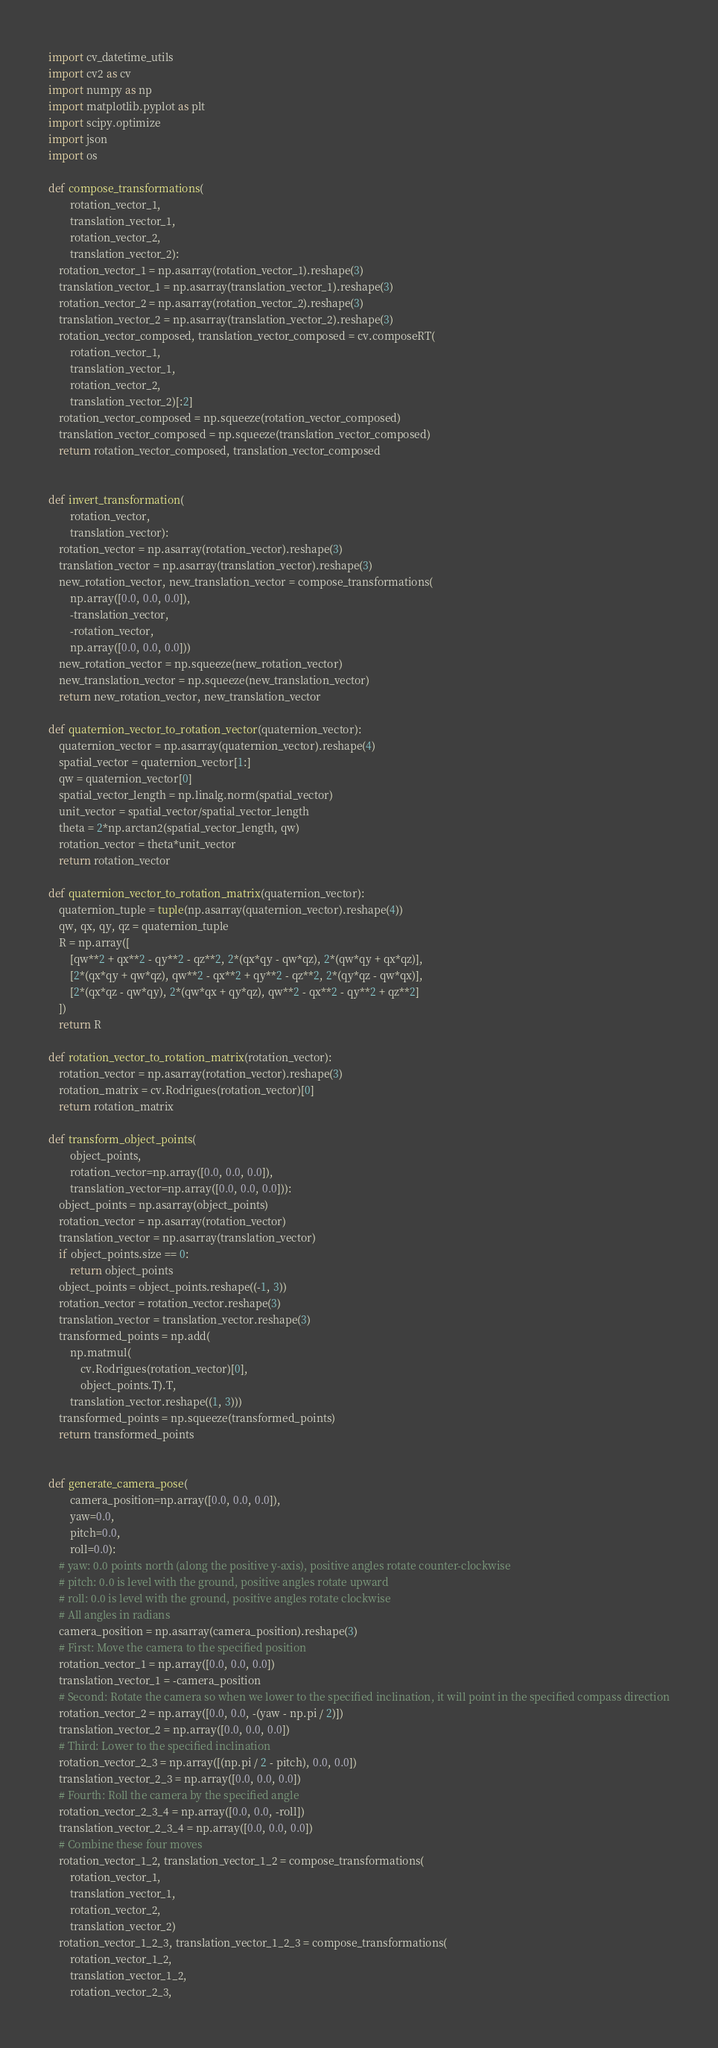Convert code to text. <code><loc_0><loc_0><loc_500><loc_500><_Python_>import cv_datetime_utils
import cv2 as cv
import numpy as np
import matplotlib.pyplot as plt
import scipy.optimize
import json
import os

def compose_transformations(
        rotation_vector_1,
        translation_vector_1,
        rotation_vector_2,
        translation_vector_2):
    rotation_vector_1 = np.asarray(rotation_vector_1).reshape(3)
    translation_vector_1 = np.asarray(translation_vector_1).reshape(3)
    rotation_vector_2 = np.asarray(rotation_vector_2).reshape(3)
    translation_vector_2 = np.asarray(translation_vector_2).reshape(3)
    rotation_vector_composed, translation_vector_composed = cv.composeRT(
        rotation_vector_1,
        translation_vector_1,
        rotation_vector_2,
        translation_vector_2)[:2]
    rotation_vector_composed = np.squeeze(rotation_vector_composed)
    translation_vector_composed = np.squeeze(translation_vector_composed)
    return rotation_vector_composed, translation_vector_composed


def invert_transformation(
        rotation_vector,
        translation_vector):
    rotation_vector = np.asarray(rotation_vector).reshape(3)
    translation_vector = np.asarray(translation_vector).reshape(3)
    new_rotation_vector, new_translation_vector = compose_transformations(
        np.array([0.0, 0.0, 0.0]),
        -translation_vector,
        -rotation_vector,
        np.array([0.0, 0.0, 0.0]))
    new_rotation_vector = np.squeeze(new_rotation_vector)
    new_translation_vector = np.squeeze(new_translation_vector)
    return new_rotation_vector, new_translation_vector

def quaternion_vector_to_rotation_vector(quaternion_vector):
    quaternion_vector = np.asarray(quaternion_vector).reshape(4)
    spatial_vector = quaternion_vector[1:]
    qw = quaternion_vector[0]
    spatial_vector_length = np.linalg.norm(spatial_vector)
    unit_vector = spatial_vector/spatial_vector_length
    theta = 2*np.arctan2(spatial_vector_length, qw)
    rotation_vector = theta*unit_vector
    return rotation_vector

def quaternion_vector_to_rotation_matrix(quaternion_vector):
    quaternion_tuple = tuple(np.asarray(quaternion_vector).reshape(4))
    qw, qx, qy, qz = quaternion_tuple
    R = np.array([
        [qw**2 + qx**2 - qy**2 - qz**2, 2*(qx*qy - qw*qz), 2*(qw*qy + qx*qz)],
        [2*(qx*qy + qw*qz), qw**2 - qx**2 + qy**2 - qz**2, 2*(qy*qz - qw*qx)],
        [2*(qx*qz - qw*qy), 2*(qw*qx + qy*qz), qw**2 - qx**2 - qy**2 + qz**2]
    ])
    return R

def rotation_vector_to_rotation_matrix(rotation_vector):
    rotation_vector = np.asarray(rotation_vector).reshape(3)
    rotation_matrix = cv.Rodrigues(rotation_vector)[0]
    return rotation_matrix

def transform_object_points(
        object_points,
        rotation_vector=np.array([0.0, 0.0, 0.0]),
        translation_vector=np.array([0.0, 0.0, 0.0])):
    object_points = np.asarray(object_points)
    rotation_vector = np.asarray(rotation_vector)
    translation_vector = np.asarray(translation_vector)
    if object_points.size == 0:
        return object_points
    object_points = object_points.reshape((-1, 3))
    rotation_vector = rotation_vector.reshape(3)
    translation_vector = translation_vector.reshape(3)
    transformed_points = np.add(
        np.matmul(
            cv.Rodrigues(rotation_vector)[0],
            object_points.T).T,
        translation_vector.reshape((1, 3)))
    transformed_points = np.squeeze(transformed_points)
    return transformed_points


def generate_camera_pose(
        camera_position=np.array([0.0, 0.0, 0.0]),
        yaw=0.0,
        pitch=0.0,
        roll=0.0):
    # yaw: 0.0 points north (along the positive y-axis), positive angles rotate counter-clockwise
    # pitch: 0.0 is level with the ground, positive angles rotate upward
    # roll: 0.0 is level with the ground, positive angles rotate clockwise
    # All angles in radians
    camera_position = np.asarray(camera_position).reshape(3)
    # First: Move the camera to the specified position
    rotation_vector_1 = np.array([0.0, 0.0, 0.0])
    translation_vector_1 = -camera_position
    # Second: Rotate the camera so when we lower to the specified inclination, it will point in the specified compass direction
    rotation_vector_2 = np.array([0.0, 0.0, -(yaw - np.pi / 2)])
    translation_vector_2 = np.array([0.0, 0.0, 0.0])
    # Third: Lower to the specified inclination
    rotation_vector_2_3 = np.array([(np.pi / 2 - pitch), 0.0, 0.0])
    translation_vector_2_3 = np.array([0.0, 0.0, 0.0])
    # Fourth: Roll the camera by the specified angle
    rotation_vector_2_3_4 = np.array([0.0, 0.0, -roll])
    translation_vector_2_3_4 = np.array([0.0, 0.0, 0.0])
    # Combine these four moves
    rotation_vector_1_2, translation_vector_1_2 = compose_transformations(
        rotation_vector_1,
        translation_vector_1,
        rotation_vector_2,
        translation_vector_2)
    rotation_vector_1_2_3, translation_vector_1_2_3 = compose_transformations(
        rotation_vector_1_2,
        translation_vector_1_2,
        rotation_vector_2_3,</code> 